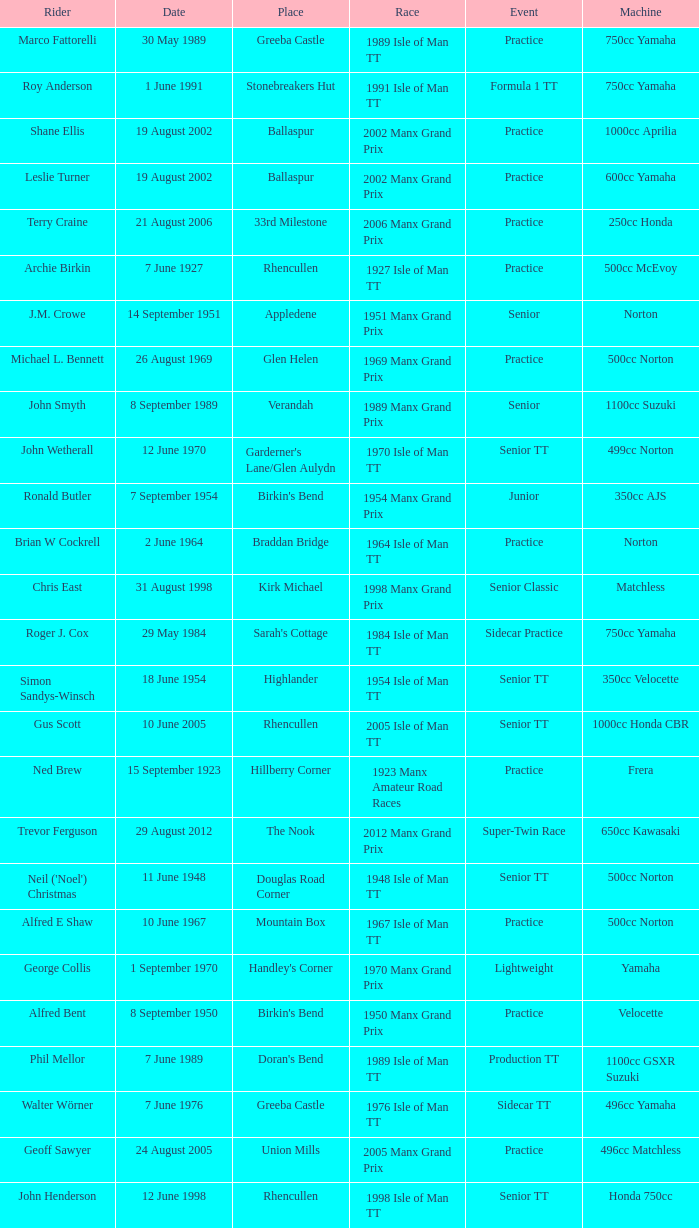Where was the 249cc Yamaha? Glentramman. 